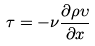Convert formula to latex. <formula><loc_0><loc_0><loc_500><loc_500>\tau = - \nu \frac { \partial \rho \upsilon } { \partial x }</formula> 